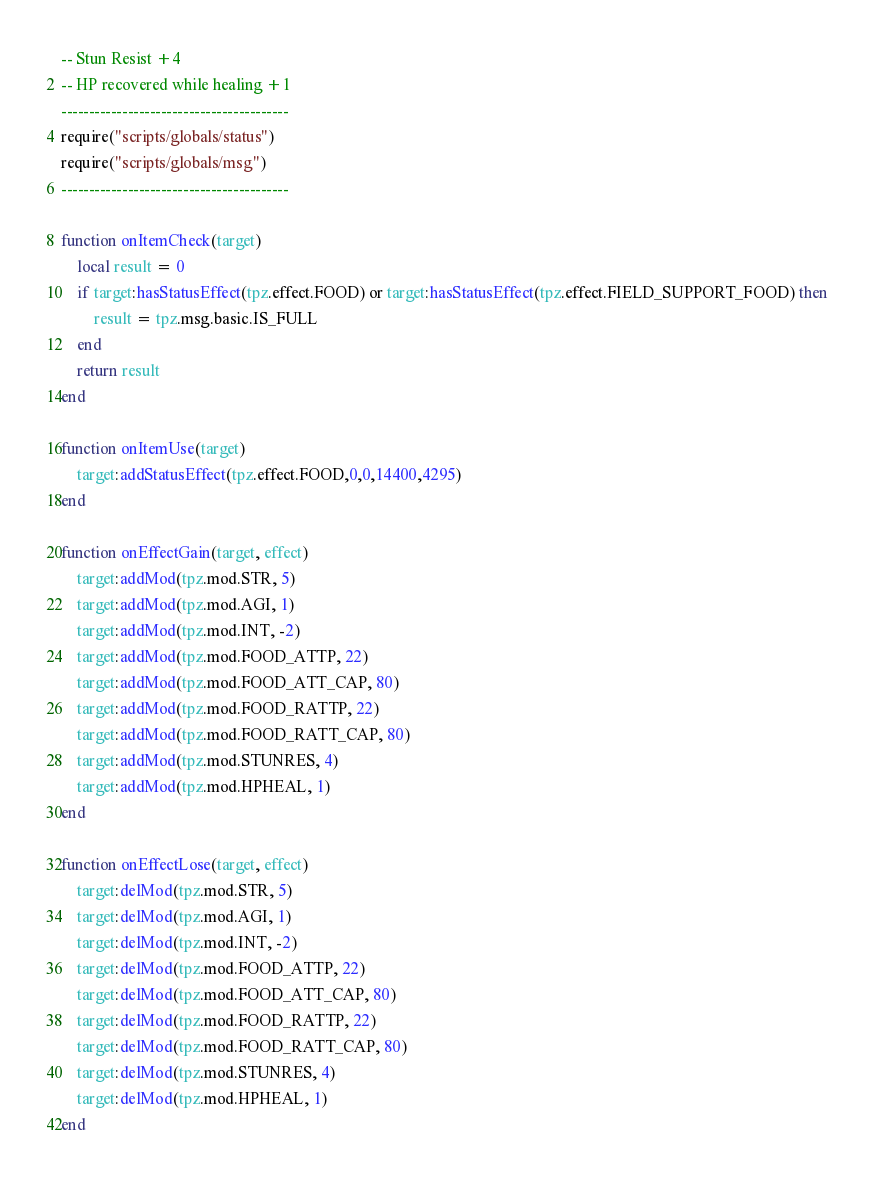<code> <loc_0><loc_0><loc_500><loc_500><_Lua_>-- Stun Resist +4
-- HP recovered while healing +1
-----------------------------------------
require("scripts/globals/status")
require("scripts/globals/msg")
-----------------------------------------

function onItemCheck(target)
    local result = 0
    if target:hasStatusEffect(tpz.effect.FOOD) or target:hasStatusEffect(tpz.effect.FIELD_SUPPORT_FOOD) then
        result = tpz.msg.basic.IS_FULL
    end
    return result
end

function onItemUse(target)
    target:addStatusEffect(tpz.effect.FOOD,0,0,14400,4295)
end

function onEffectGain(target, effect)
    target:addMod(tpz.mod.STR, 5)
    target:addMod(tpz.mod.AGI, 1)
    target:addMod(tpz.mod.INT, -2)
    target:addMod(tpz.mod.FOOD_ATTP, 22)
    target:addMod(tpz.mod.FOOD_ATT_CAP, 80)
    target:addMod(tpz.mod.FOOD_RATTP, 22)
    target:addMod(tpz.mod.FOOD_RATT_CAP, 80)
    target:addMod(tpz.mod.STUNRES, 4)
    target:addMod(tpz.mod.HPHEAL, 1)
end

function onEffectLose(target, effect)
    target:delMod(tpz.mod.STR, 5)
    target:delMod(tpz.mod.AGI, 1)
    target:delMod(tpz.mod.INT, -2)
    target:delMod(tpz.mod.FOOD_ATTP, 22)
    target:delMod(tpz.mod.FOOD_ATT_CAP, 80)
    target:delMod(tpz.mod.FOOD_RATTP, 22)
    target:delMod(tpz.mod.FOOD_RATT_CAP, 80)
    target:delMod(tpz.mod.STUNRES, 4)
    target:delMod(tpz.mod.HPHEAL, 1)
end
</code> 